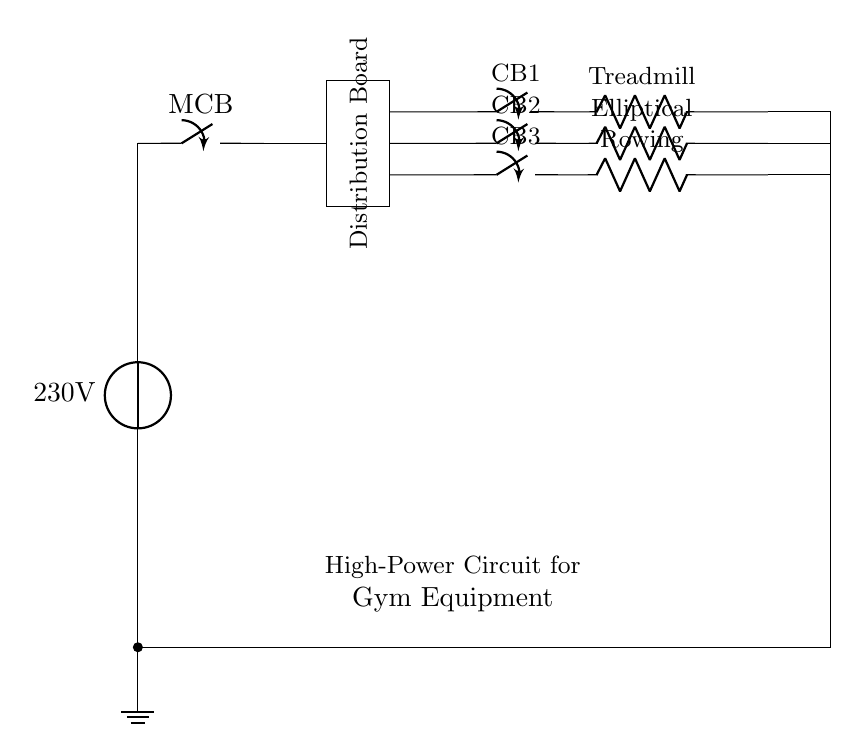What is the voltage of this circuit? The voltage is 230 volts, as indicated by the voltage source in the circuit diagram.
Answer: 230 volts What type of appliances are connected to this circuit? The appliances connected include a treadmill, an elliptical trainer, and a rowing machine, as labeled in the circuit components.
Answer: Treadmill, elliptical trainer, rowing machine How many circuit breakers are present in the circuit? There are three circuit breakers labeled as CB1, CB2, and CB3, each corresponding to a different piece of equipment.
Answer: Three What is the function of the distribution board in this circuit? The distribution board serves to organize and direct the power supply from the main circuit breaker to various circuits feeding the gym equipment.
Answer: Organize power supply What is the purpose of the ground symbol in the circuit? The ground symbol indicates a connection to the earth, providing safety by allowing excess current to safely disperse into the ground, preventing electrical shock.
Answer: Safety What is the return path for the circuit? The return path is established from the various equipment through their respective connections back to the main power supply, completing the circuit.
Answer: Main power supply What might happen if one of the circuit breakers is open? If one of the circuit breakers is open, the corresponding appliance (treadmill, elliptical, or rowing machine) will not operate, as the circuit is incomplete.
Answer: Appliance won't operate 